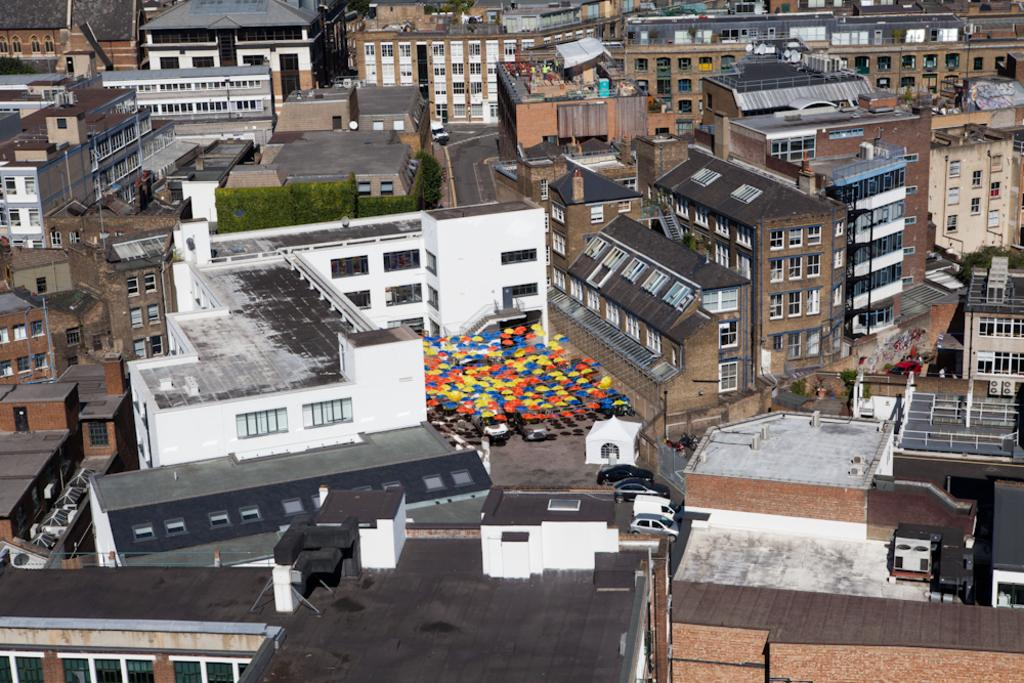What type of structures can be seen in the image? There are buildings in the image. What other natural elements are present in the image? There are trees in the image. Are there any vehicles visible in the image? Yes, there are cars in the image. Can you describe the colors of the objects in the image? There are multi-colored objects in the image. What type of reaction can be seen on the crib in the image? There is no crib present in the image, and therefore no reaction can be observed. Can you describe the smile on the person in the image? There is no person present in the image, and therefore no smile can be observed. 